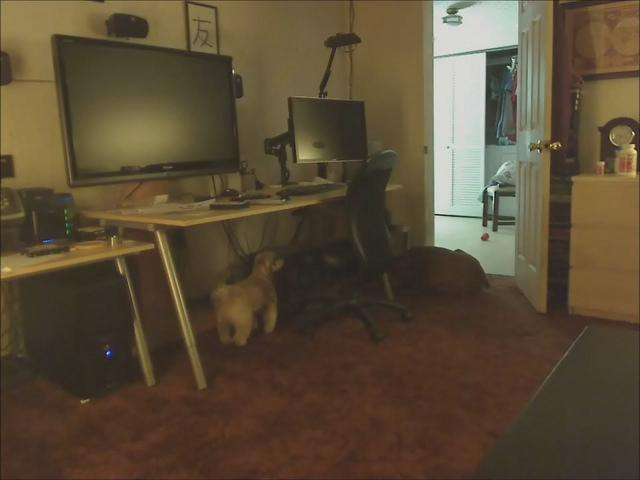The thing that is under the desk belongs to what family?

Choices:
A) canidae
B) addams
C) partridge
D) bovidae canidae 